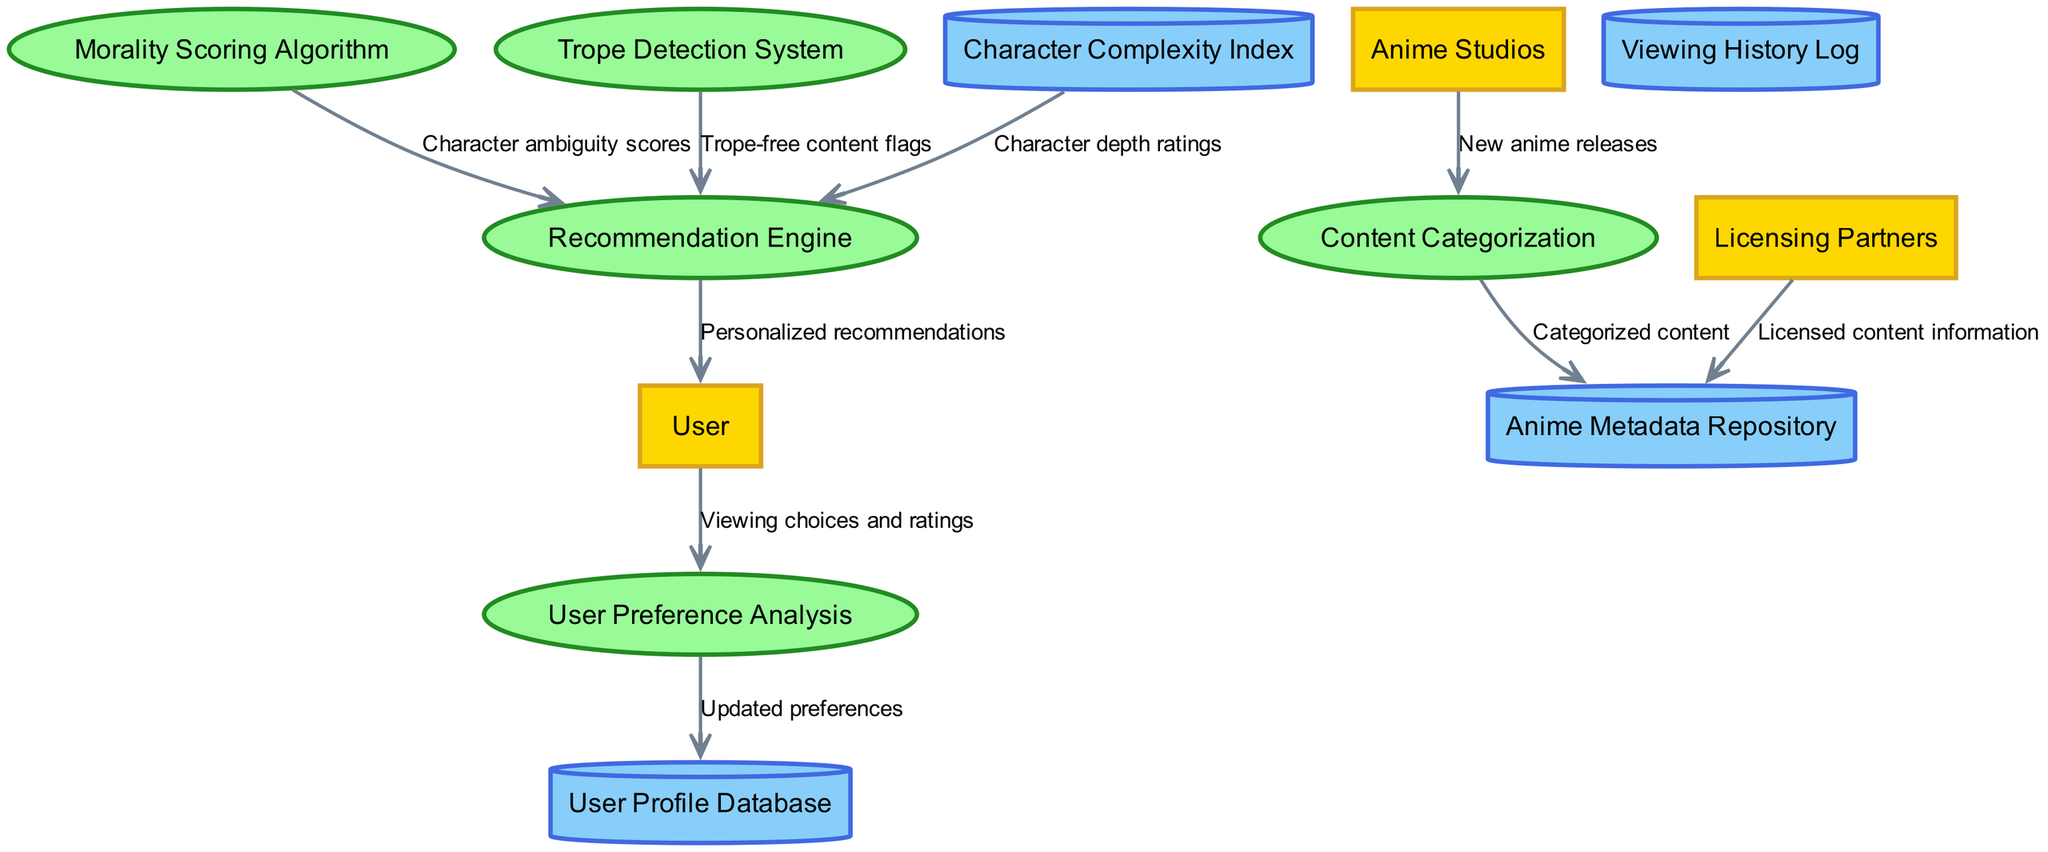What's the total number of external entities? There are three external entities listed in the diagram: User, Anime Studios, and Licensing Partners. This is confirmed by counting the items in the "external_entities" list.
Answer: 3 Which process is responsible for tracking user viewing choices and ratings? The process that receives viewing choices and ratings directly from the User is the "User Preference Analysis" process, indicated by the data flow labeled "Viewing choices and ratings."
Answer: User Preference Analysis How many data flows are present in the diagram? The diagram contains eight distinct data flows as indicated by the "data_flows" list, each representing a connection between entities, processes, and data stores.
Answer: 8 What information does the "Morality Scoring Algorithm" send to the "Recommendation Engine"? The "Morality Scoring Algorithm" sends "Character ambiguity scores" to the "Recommendation Engine," as indicated by the respective data flow between these two processes.
Answer: Character ambiguity scores Which entities provide data to the "Content Categorization" process? The "Content Categorization" process receives data specifically from the "Anime Studios," who send in "New anime releases," as shown by the data flow labeled accordingly.
Answer: Anime Studios Describe the flow of updated preferences from the user to data storage. The "User" sends their viewing choices and ratings to "User Preference Analysis," which then updates the "User Profile Database" with the new preferences, following the data flow labeled "Updated preferences."
Answer: User Profile Database What is the purpose of the "Trope Detection System"? The "Trope Detection System" is designed to provide "Trope-free content flags" to the "Recommendation Engine," thereby indicating content that does not rely on clichés and tropes, which is crucial for the platform's objective.
Answer: Trope-free content flags Which data store is associated with character complexity? The "Character Complexity Index" data store is directly associated with character complexity, providing depth ratings to the "Recommendation Engine," as outlined in the data flows.
Answer: Character Complexity Index 